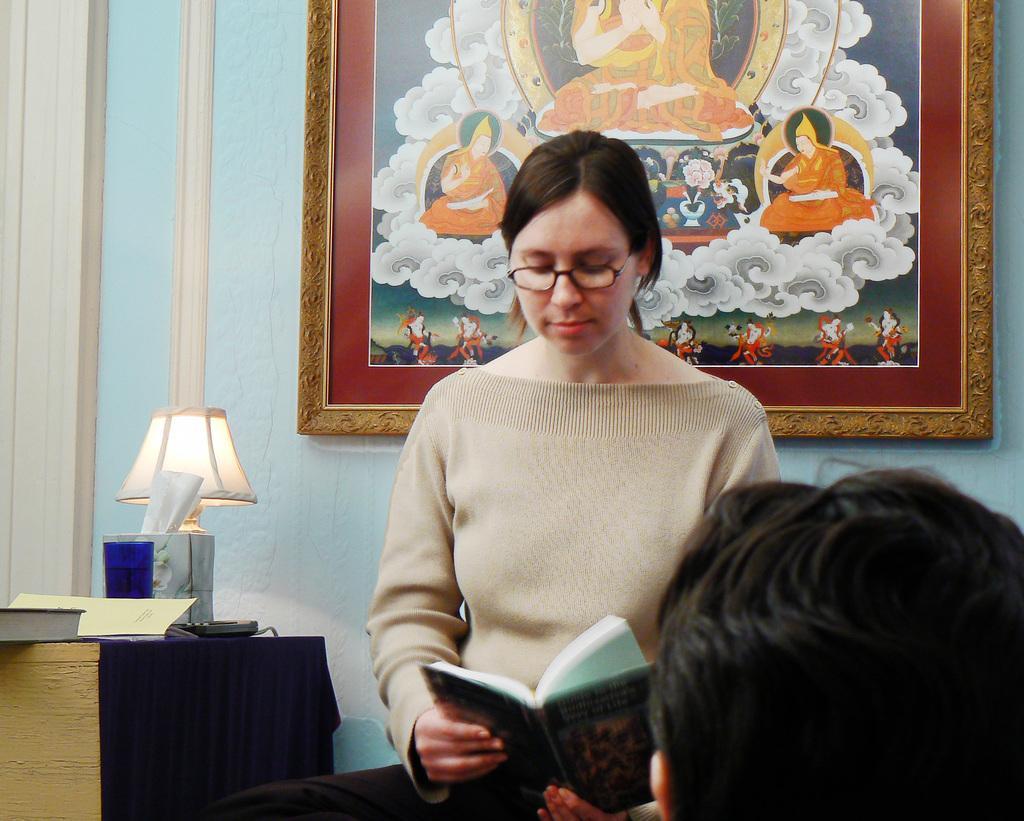How would you summarize this image in a sentence or two? In this image, there are a few people. Among them, we can see a person holding an object. We can also see the wall with a frame. We can also see a table with some objects like a lamp and some books. 